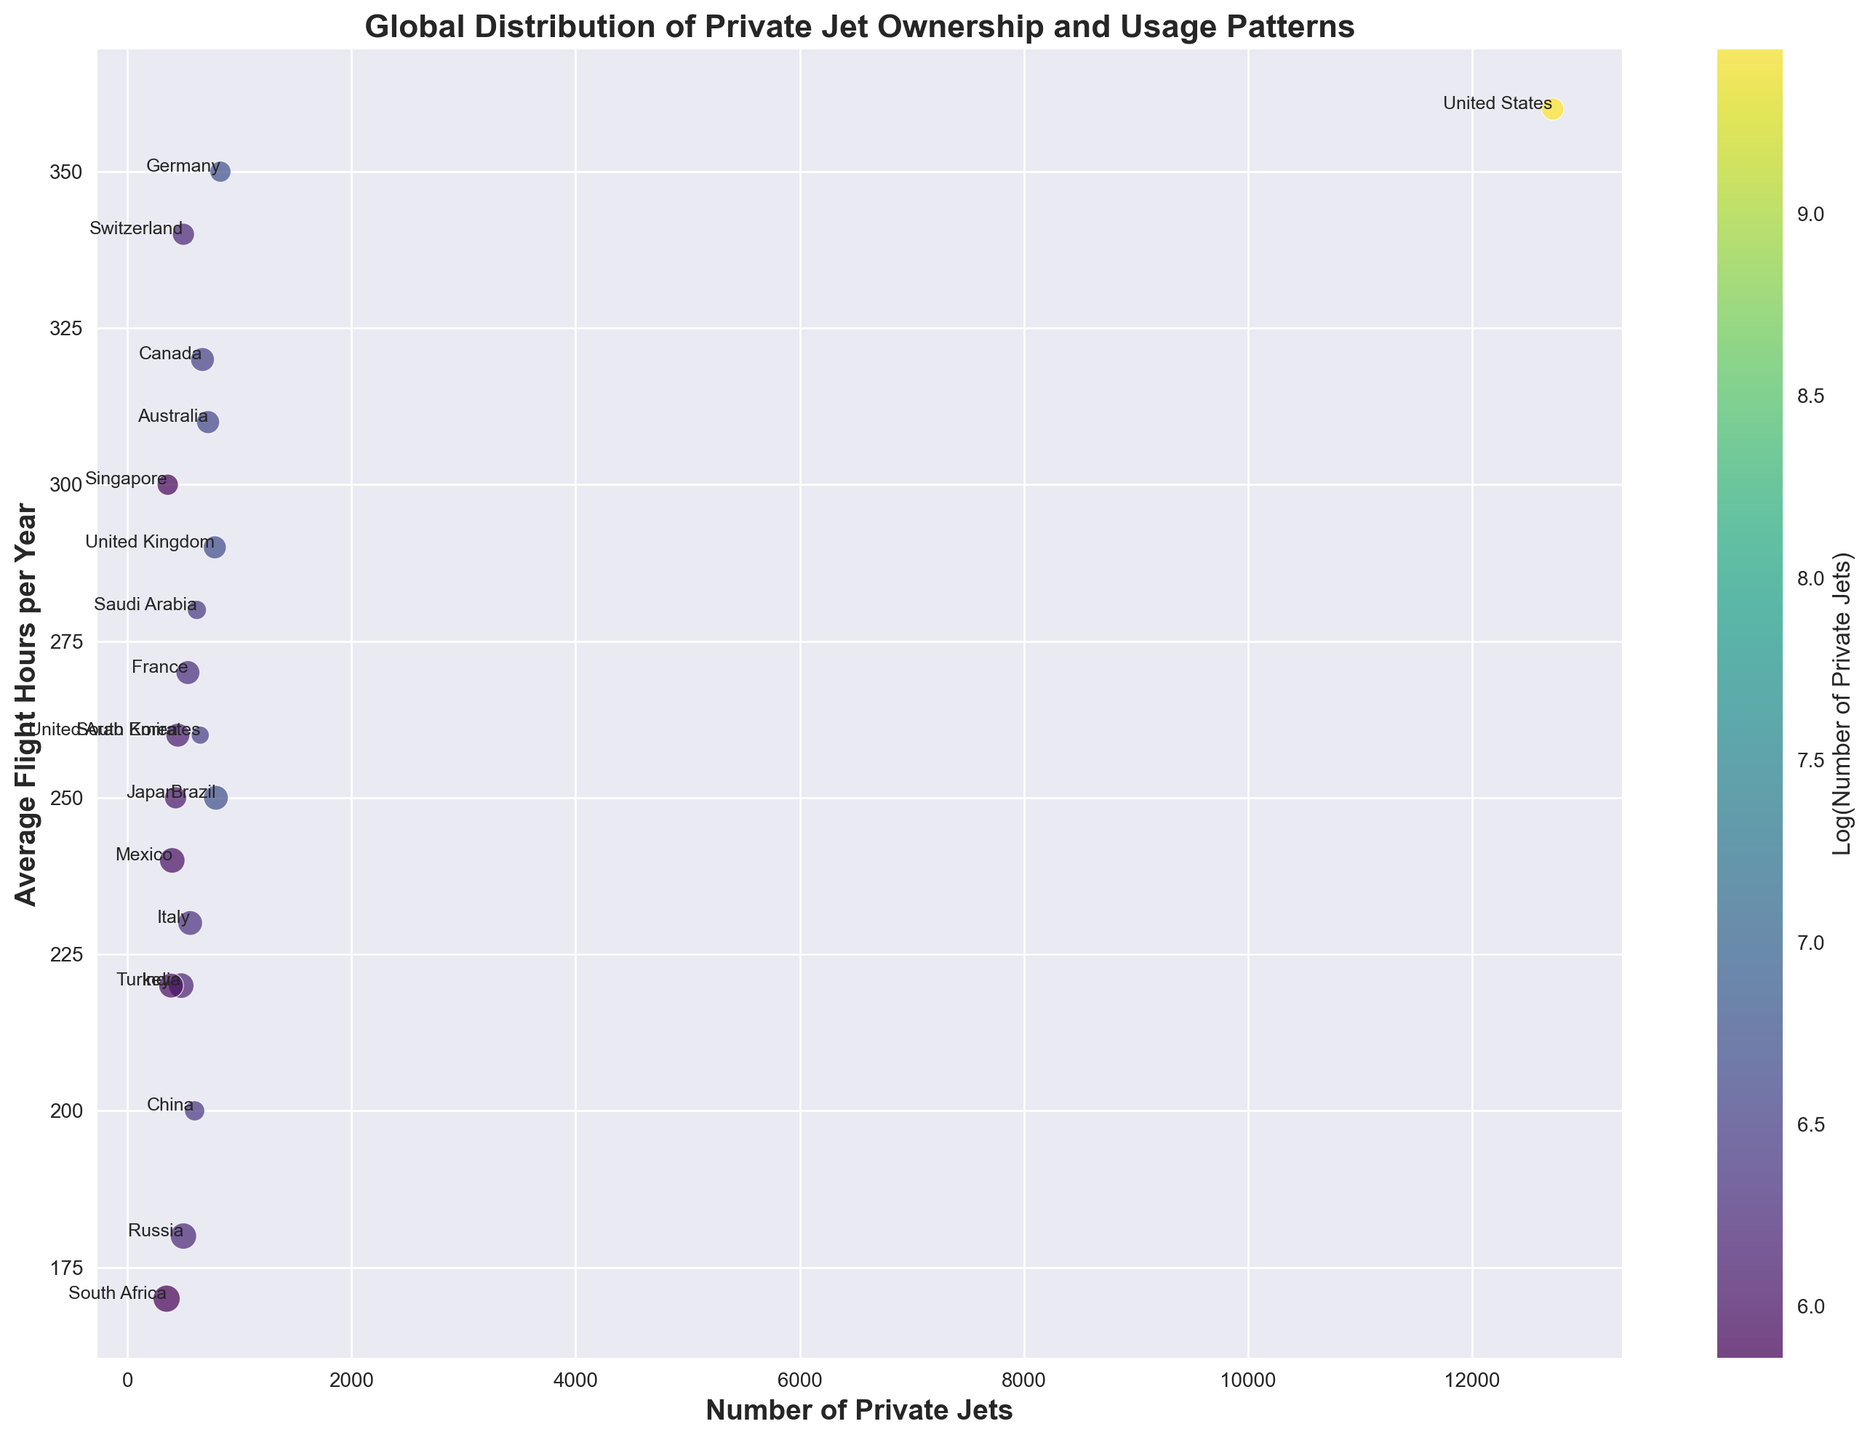Which country has the greatest number of private jets? The country with the highest number of private jets can be identified by looking at the horizontal axis for the farthest right data point. In this case, the United States is the country with the greatest number of private jets.
Answer: United States Which country has the highest average flight hours per year? To find the country with the highest average flight hours per year, check the vertical axis for the point highest up on the plot. The United States has the highest average flight hours per year.
Answer: United States Compare the number of private jets and average flight hours per year between the United Kingdom and Germany. Which country has more jets and which has more flight hours? From the plot, the United Kingdom has a slightly lower number of private jets compared to Germany but fewer average flight hours per year. Specifically, Germany has around 830 jets and 350 flight hours, whereas the United Kingdom has around 780 jets and 290 flight hours.
Answer: Germany has more jets, Germany has more flight hours Which country has the oldest average age of jets, and what is the visual clue used? The oldest average age of jets can be inferred from the largest bubble size on the plot. South Africa has the largest bubble, indicating that it has the oldest average age of jets.
Answer: South Africa Which countries have a similar number of private jets but different average flight hours per year? By visually inspecting the horizontal spread along the x-axis while observing the different vertical positions, Canada and Russia have a similar number of private jets but differing average flight hours. Canada has around 670 jets and 320 flight hours, whereas Russia has 500 jets and 180 flight hours.
Answer: Canada, Russia What is the mathematical relationship between the number of private jets and their average flight hours per year for China and India combined? Adding the number of private jets together: China (600) + India (480) = 1080.
Similarly, adding their average flight hours: China (200) + India (220) = 420.
So, China and India combined have 1080 private jets and 420 average flight hours per year.
Answer: 1080 jets, 420 flight hours Which countries have bubbles that reflect a lower-than-average age of jets, and how can you tell? Countries with smaller bubble sizes reflect a lower-than-average age of jets. By inspecting smaller bubbles, the United Arab Emirates (650 jets, 260 flight hours) and Saudi Arabia (620 jets, 280 flight hours) both feature noticeably smaller bubbles indicating newer jets.
Answer: United Arab Emirates, Saudi Arabia 